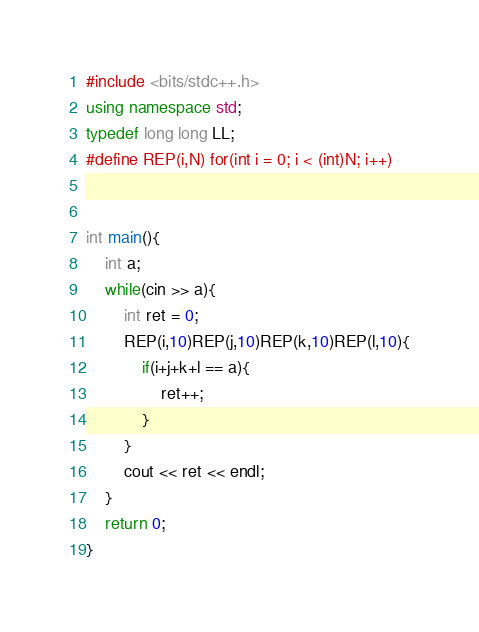<code> <loc_0><loc_0><loc_500><loc_500><_C++_>#include <bits/stdc++.h>
using namespace std;
typedef long long LL;
#define REP(i,N) for(int i = 0; i < (int)N; i++)


int main(){
	int a;
	while(cin >> a){
		int ret = 0;
		REP(i,10)REP(j,10)REP(k,10)REP(l,10){
			if(i+j+k+l == a){
				ret++;
			}
		}
		cout << ret << endl;
	}
	return 0;
}</code> 